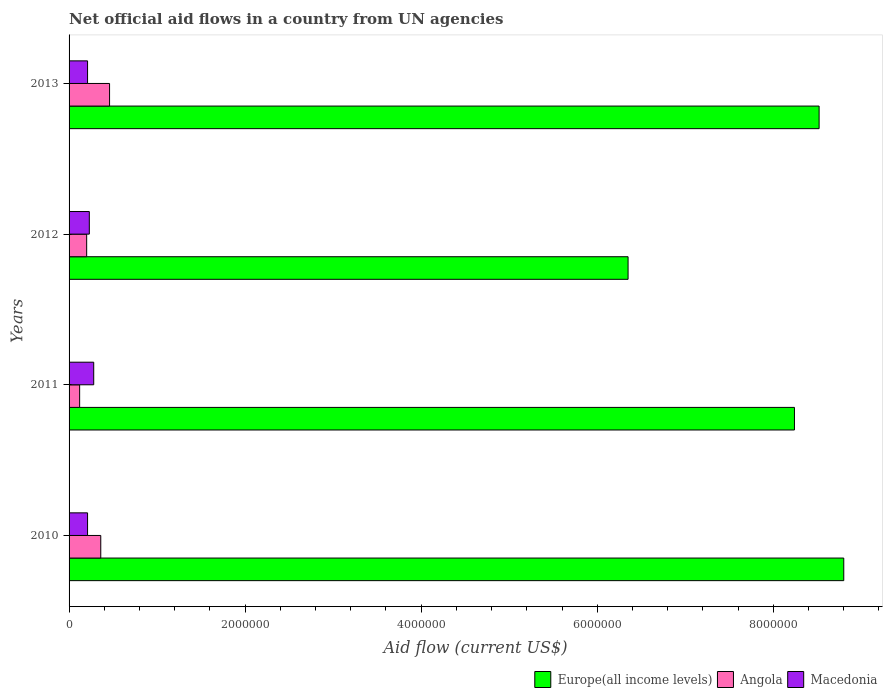How many different coloured bars are there?
Your answer should be compact. 3. How many groups of bars are there?
Your answer should be compact. 4. Are the number of bars on each tick of the Y-axis equal?
Give a very brief answer. Yes. How many bars are there on the 1st tick from the top?
Your answer should be compact. 3. How many bars are there on the 3rd tick from the bottom?
Offer a terse response. 3. What is the label of the 1st group of bars from the top?
Your answer should be very brief. 2013. What is the net official aid flow in Macedonia in 2013?
Your answer should be compact. 2.10e+05. Across all years, what is the maximum net official aid flow in Europe(all income levels)?
Keep it short and to the point. 8.80e+06. Across all years, what is the minimum net official aid flow in Angola?
Keep it short and to the point. 1.20e+05. In which year was the net official aid flow in Europe(all income levels) maximum?
Give a very brief answer. 2010. What is the total net official aid flow in Angola in the graph?
Make the answer very short. 1.14e+06. What is the difference between the net official aid flow in Europe(all income levels) in 2012 and that in 2013?
Provide a short and direct response. -2.17e+06. What is the difference between the net official aid flow in Angola in 2011 and the net official aid flow in Europe(all income levels) in 2012?
Offer a very short reply. -6.23e+06. What is the average net official aid flow in Europe(all income levels) per year?
Make the answer very short. 7.98e+06. In the year 2013, what is the difference between the net official aid flow in Angola and net official aid flow in Macedonia?
Provide a short and direct response. 2.50e+05. In how many years, is the net official aid flow in Angola greater than 3200000 US$?
Offer a terse response. 0. What is the ratio of the net official aid flow in Europe(all income levels) in 2010 to that in 2012?
Keep it short and to the point. 1.39. Is the net official aid flow in Angola in 2011 less than that in 2012?
Ensure brevity in your answer.  Yes. Is the difference between the net official aid flow in Angola in 2011 and 2012 greater than the difference between the net official aid flow in Macedonia in 2011 and 2012?
Offer a terse response. No. What is the difference between the highest and the second highest net official aid flow in Macedonia?
Make the answer very short. 5.00e+04. What is the difference between the highest and the lowest net official aid flow in Angola?
Your response must be concise. 3.40e+05. Is the sum of the net official aid flow in Angola in 2010 and 2011 greater than the maximum net official aid flow in Europe(all income levels) across all years?
Make the answer very short. No. What does the 2nd bar from the top in 2011 represents?
Ensure brevity in your answer.  Angola. What does the 2nd bar from the bottom in 2011 represents?
Ensure brevity in your answer.  Angola. Is it the case that in every year, the sum of the net official aid flow in Angola and net official aid flow in Europe(all income levels) is greater than the net official aid flow in Macedonia?
Keep it short and to the point. Yes. Does the graph contain any zero values?
Keep it short and to the point. No. What is the title of the graph?
Your response must be concise. Net official aid flows in a country from UN agencies. What is the label or title of the X-axis?
Your answer should be compact. Aid flow (current US$). What is the Aid flow (current US$) of Europe(all income levels) in 2010?
Give a very brief answer. 8.80e+06. What is the Aid flow (current US$) of Angola in 2010?
Your answer should be very brief. 3.60e+05. What is the Aid flow (current US$) in Europe(all income levels) in 2011?
Your answer should be compact. 8.24e+06. What is the Aid flow (current US$) of Angola in 2011?
Make the answer very short. 1.20e+05. What is the Aid flow (current US$) in Macedonia in 2011?
Offer a very short reply. 2.80e+05. What is the Aid flow (current US$) in Europe(all income levels) in 2012?
Offer a terse response. 6.35e+06. What is the Aid flow (current US$) of Macedonia in 2012?
Ensure brevity in your answer.  2.30e+05. What is the Aid flow (current US$) in Europe(all income levels) in 2013?
Provide a short and direct response. 8.52e+06. Across all years, what is the maximum Aid flow (current US$) in Europe(all income levels)?
Give a very brief answer. 8.80e+06. Across all years, what is the maximum Aid flow (current US$) of Angola?
Offer a very short reply. 4.60e+05. Across all years, what is the maximum Aid flow (current US$) of Macedonia?
Your answer should be compact. 2.80e+05. Across all years, what is the minimum Aid flow (current US$) in Europe(all income levels)?
Make the answer very short. 6.35e+06. Across all years, what is the minimum Aid flow (current US$) in Macedonia?
Keep it short and to the point. 2.10e+05. What is the total Aid flow (current US$) of Europe(all income levels) in the graph?
Provide a succinct answer. 3.19e+07. What is the total Aid flow (current US$) of Angola in the graph?
Offer a terse response. 1.14e+06. What is the total Aid flow (current US$) of Macedonia in the graph?
Your answer should be compact. 9.30e+05. What is the difference between the Aid flow (current US$) of Europe(all income levels) in 2010 and that in 2011?
Give a very brief answer. 5.60e+05. What is the difference between the Aid flow (current US$) in Angola in 2010 and that in 2011?
Your response must be concise. 2.40e+05. What is the difference between the Aid flow (current US$) in Europe(all income levels) in 2010 and that in 2012?
Offer a terse response. 2.45e+06. What is the difference between the Aid flow (current US$) in Angola in 2010 and that in 2012?
Keep it short and to the point. 1.60e+05. What is the difference between the Aid flow (current US$) in Macedonia in 2010 and that in 2012?
Keep it short and to the point. -2.00e+04. What is the difference between the Aid flow (current US$) of Macedonia in 2010 and that in 2013?
Your answer should be very brief. 0. What is the difference between the Aid flow (current US$) of Europe(all income levels) in 2011 and that in 2012?
Provide a short and direct response. 1.89e+06. What is the difference between the Aid flow (current US$) in Europe(all income levels) in 2011 and that in 2013?
Provide a succinct answer. -2.80e+05. What is the difference between the Aid flow (current US$) in Europe(all income levels) in 2012 and that in 2013?
Provide a short and direct response. -2.17e+06. What is the difference between the Aid flow (current US$) of Europe(all income levels) in 2010 and the Aid flow (current US$) of Angola in 2011?
Your answer should be very brief. 8.68e+06. What is the difference between the Aid flow (current US$) of Europe(all income levels) in 2010 and the Aid flow (current US$) of Macedonia in 2011?
Offer a terse response. 8.52e+06. What is the difference between the Aid flow (current US$) in Angola in 2010 and the Aid flow (current US$) in Macedonia in 2011?
Offer a terse response. 8.00e+04. What is the difference between the Aid flow (current US$) of Europe(all income levels) in 2010 and the Aid flow (current US$) of Angola in 2012?
Make the answer very short. 8.60e+06. What is the difference between the Aid flow (current US$) of Europe(all income levels) in 2010 and the Aid flow (current US$) of Macedonia in 2012?
Provide a succinct answer. 8.57e+06. What is the difference between the Aid flow (current US$) in Europe(all income levels) in 2010 and the Aid flow (current US$) in Angola in 2013?
Your answer should be very brief. 8.34e+06. What is the difference between the Aid flow (current US$) in Europe(all income levels) in 2010 and the Aid flow (current US$) in Macedonia in 2013?
Your answer should be very brief. 8.59e+06. What is the difference between the Aid flow (current US$) in Europe(all income levels) in 2011 and the Aid flow (current US$) in Angola in 2012?
Make the answer very short. 8.04e+06. What is the difference between the Aid flow (current US$) of Europe(all income levels) in 2011 and the Aid flow (current US$) of Macedonia in 2012?
Keep it short and to the point. 8.01e+06. What is the difference between the Aid flow (current US$) in Europe(all income levels) in 2011 and the Aid flow (current US$) in Angola in 2013?
Your response must be concise. 7.78e+06. What is the difference between the Aid flow (current US$) of Europe(all income levels) in 2011 and the Aid flow (current US$) of Macedonia in 2013?
Your response must be concise. 8.03e+06. What is the difference between the Aid flow (current US$) in Europe(all income levels) in 2012 and the Aid flow (current US$) in Angola in 2013?
Your response must be concise. 5.89e+06. What is the difference between the Aid flow (current US$) in Europe(all income levels) in 2012 and the Aid flow (current US$) in Macedonia in 2013?
Your answer should be very brief. 6.14e+06. What is the average Aid flow (current US$) in Europe(all income levels) per year?
Your answer should be very brief. 7.98e+06. What is the average Aid flow (current US$) of Angola per year?
Give a very brief answer. 2.85e+05. What is the average Aid flow (current US$) of Macedonia per year?
Ensure brevity in your answer.  2.32e+05. In the year 2010, what is the difference between the Aid flow (current US$) in Europe(all income levels) and Aid flow (current US$) in Angola?
Make the answer very short. 8.44e+06. In the year 2010, what is the difference between the Aid flow (current US$) in Europe(all income levels) and Aid flow (current US$) in Macedonia?
Provide a short and direct response. 8.59e+06. In the year 2011, what is the difference between the Aid flow (current US$) in Europe(all income levels) and Aid flow (current US$) in Angola?
Your answer should be very brief. 8.12e+06. In the year 2011, what is the difference between the Aid flow (current US$) of Europe(all income levels) and Aid flow (current US$) of Macedonia?
Your answer should be very brief. 7.96e+06. In the year 2012, what is the difference between the Aid flow (current US$) of Europe(all income levels) and Aid flow (current US$) of Angola?
Your answer should be compact. 6.15e+06. In the year 2012, what is the difference between the Aid flow (current US$) in Europe(all income levels) and Aid flow (current US$) in Macedonia?
Your answer should be compact. 6.12e+06. In the year 2012, what is the difference between the Aid flow (current US$) of Angola and Aid flow (current US$) of Macedonia?
Give a very brief answer. -3.00e+04. In the year 2013, what is the difference between the Aid flow (current US$) in Europe(all income levels) and Aid flow (current US$) in Angola?
Ensure brevity in your answer.  8.06e+06. In the year 2013, what is the difference between the Aid flow (current US$) in Europe(all income levels) and Aid flow (current US$) in Macedonia?
Your response must be concise. 8.31e+06. What is the ratio of the Aid flow (current US$) of Europe(all income levels) in 2010 to that in 2011?
Provide a short and direct response. 1.07. What is the ratio of the Aid flow (current US$) in Angola in 2010 to that in 2011?
Offer a terse response. 3. What is the ratio of the Aid flow (current US$) in Europe(all income levels) in 2010 to that in 2012?
Keep it short and to the point. 1.39. What is the ratio of the Aid flow (current US$) in Macedonia in 2010 to that in 2012?
Offer a very short reply. 0.91. What is the ratio of the Aid flow (current US$) in Europe(all income levels) in 2010 to that in 2013?
Provide a short and direct response. 1.03. What is the ratio of the Aid flow (current US$) of Angola in 2010 to that in 2013?
Ensure brevity in your answer.  0.78. What is the ratio of the Aid flow (current US$) of Europe(all income levels) in 2011 to that in 2012?
Make the answer very short. 1.3. What is the ratio of the Aid flow (current US$) in Macedonia in 2011 to that in 2012?
Your answer should be compact. 1.22. What is the ratio of the Aid flow (current US$) of Europe(all income levels) in 2011 to that in 2013?
Ensure brevity in your answer.  0.97. What is the ratio of the Aid flow (current US$) of Angola in 2011 to that in 2013?
Give a very brief answer. 0.26. What is the ratio of the Aid flow (current US$) in Europe(all income levels) in 2012 to that in 2013?
Ensure brevity in your answer.  0.75. What is the ratio of the Aid flow (current US$) in Angola in 2012 to that in 2013?
Your answer should be very brief. 0.43. What is the ratio of the Aid flow (current US$) in Macedonia in 2012 to that in 2013?
Ensure brevity in your answer.  1.1. What is the difference between the highest and the second highest Aid flow (current US$) in Angola?
Your response must be concise. 1.00e+05. What is the difference between the highest and the lowest Aid flow (current US$) of Europe(all income levels)?
Make the answer very short. 2.45e+06. 